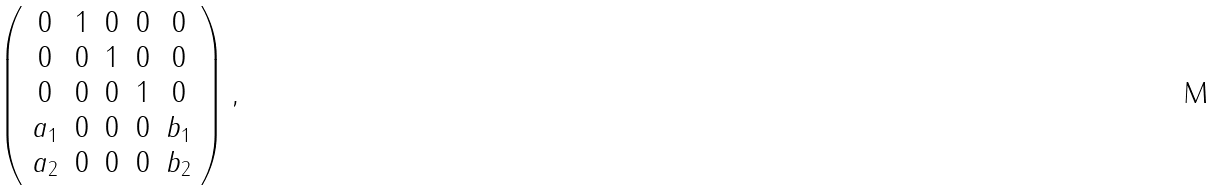Convert formula to latex. <formula><loc_0><loc_0><loc_500><loc_500>\left ( \begin{array} { c c c c c } 0 & 1 & 0 & 0 & 0 \\ 0 & 0 & 1 & 0 & 0 \\ 0 & 0 & 0 & 1 & 0 \\ a _ { 1 } & 0 & 0 & 0 & b _ { 1 } \\ a _ { 2 } & 0 & 0 & 0 & b _ { 2 } \end{array} \right ) ,</formula> 